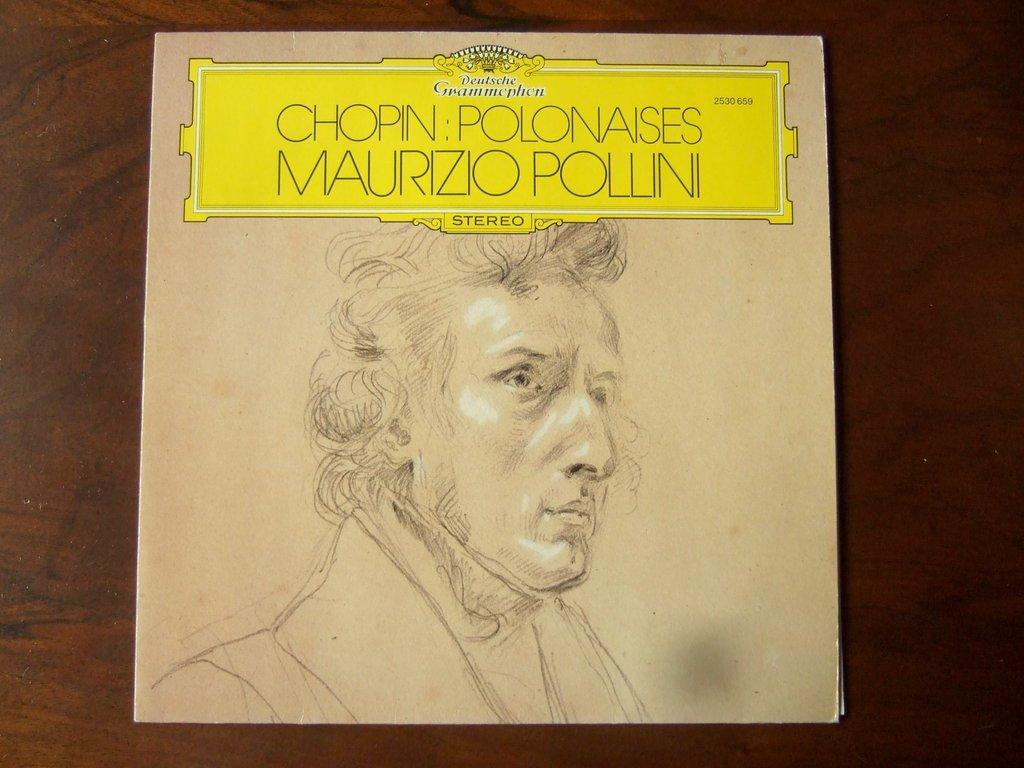What is the main subject in the center of the image? There is a poster in the center of the image. What is the poster attached to? The poster is on a wooden wall. What can be seen in the drawing on the poster? The poster contains a drawing of a person. What else is featured on the poster besides the drawing? There is text on the poster. What type of lace can be seen on the person's clothing in the image? There is no lace visible on the person's clothing in the image, as the provided facts only mention a drawing of a person on the poster. 